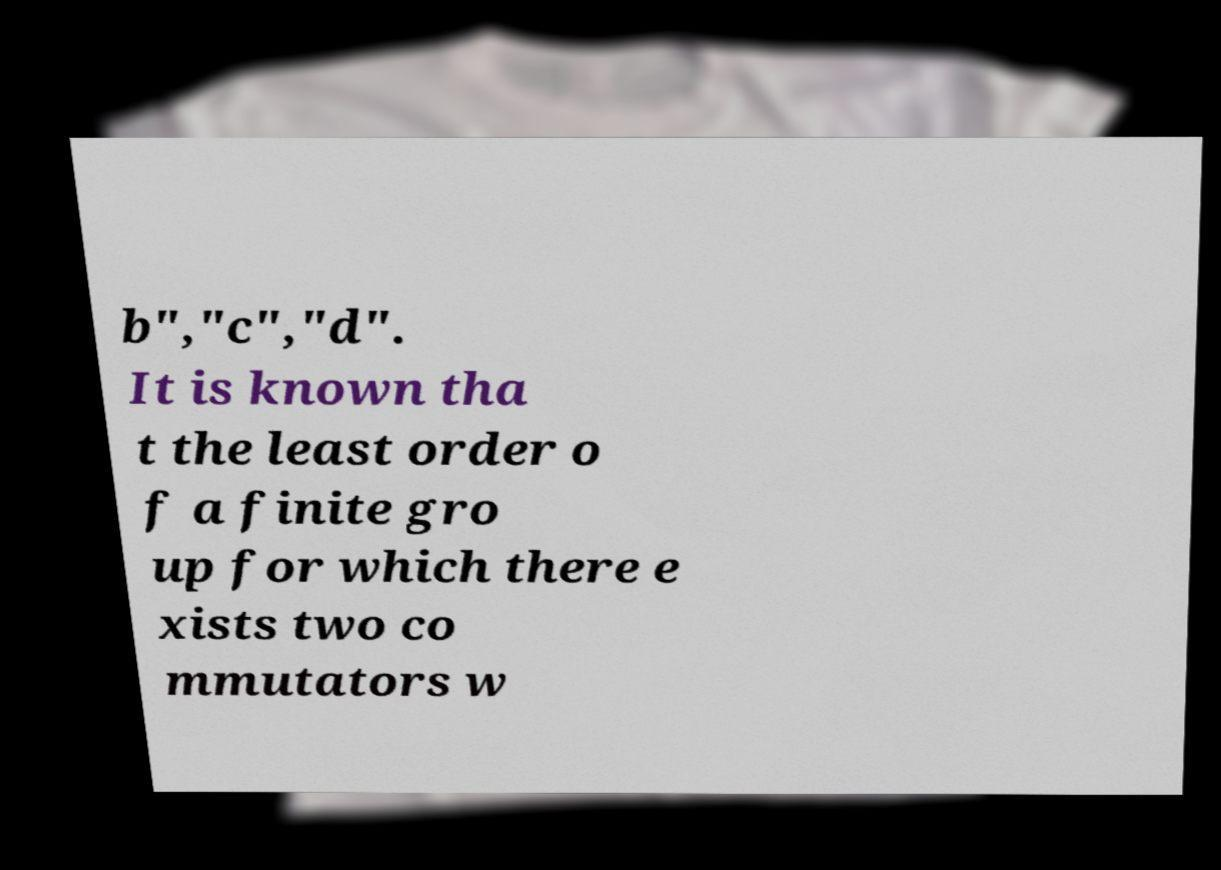For documentation purposes, I need the text within this image transcribed. Could you provide that? b","c","d". It is known tha t the least order o f a finite gro up for which there e xists two co mmutators w 